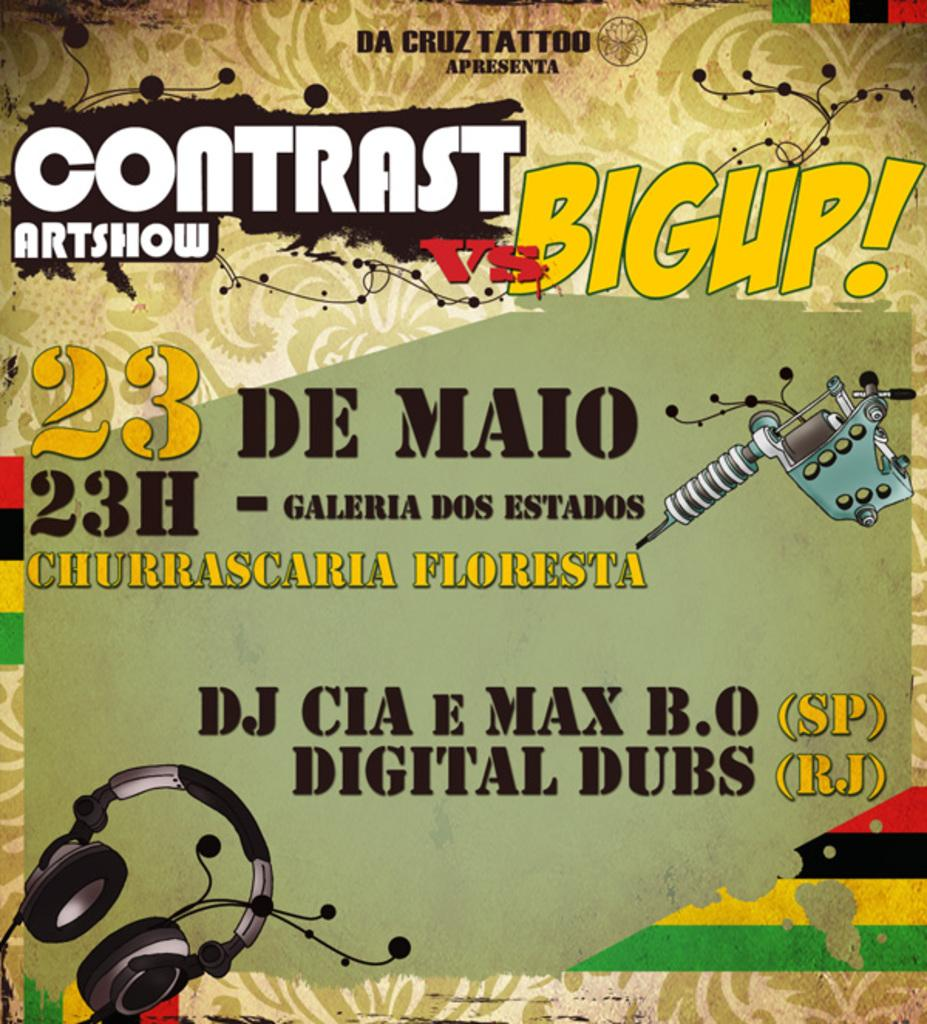<image>
Provide a brief description of the given image. An Contrast Art Show vs Bigup advertisement from Da Cruz Tattoo. 